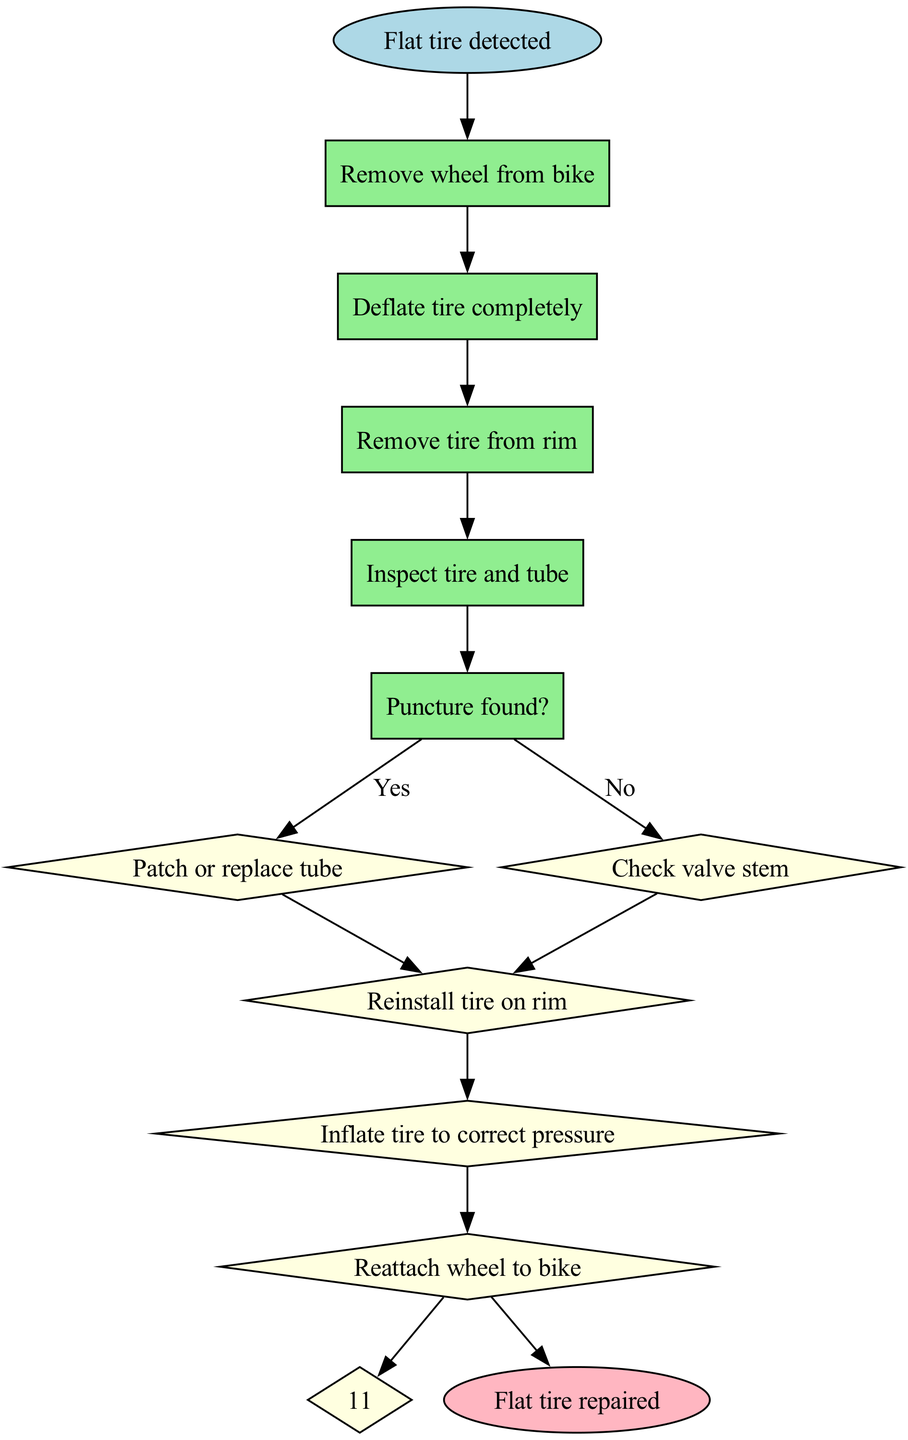What is the first step to take when a flat tire is detected? The diagram states that the first step is to "Remove wheel from bike". This is indicated directly after the start node.
Answer: Remove wheel from bike How many steps are there in the process? By counting the steps listed in the diagram, we see there are a total of 10 steps, from removing the wheel to reattaching it.
Answer: 10 What action occurs if a puncture is found? According to the diagram, if a puncture is found, the next step is to "Patch or replace tube". This follows the decision made at the "Puncture found?" step.
Answer: Patch or replace tube What happens if no puncture is found after inspecting the tire and tube? The diagram indicates that if no puncture is found, the next action is to "Check valve stem". This follows directly from the options presented in the "Puncture found?" decision.
Answer: Check valve stem What is the last action taken to complete the flat tire repair? The final action in the diagram is labeled as "Reattach wheel to bike", which is the last step before reaching the end of the flowchart.
Answer: Reattach wheel to bike What is the outcome if the steps are followed correctly? The end of the process states "Flat tire repaired". This outcome is achieved after following the flowchart steps from start to finish.
Answer: Flat tire repaired What type of node indicates a decision point in the diagram? The decision points in the diagram are indicated by "diamond" shaped nodes, specifically at the step labeled "Puncture found?".
Answer: Diamond Which step follows "Reinstall tire on rim"? The next step after "Reinstall tire on rim" is to "Inflate tire to correct pressure", as shown in the subsequent flow from that step.
Answer: Inflate tire to correct pressure 